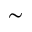Convert formula to latex. <formula><loc_0><loc_0><loc_500><loc_500>\sim</formula> 